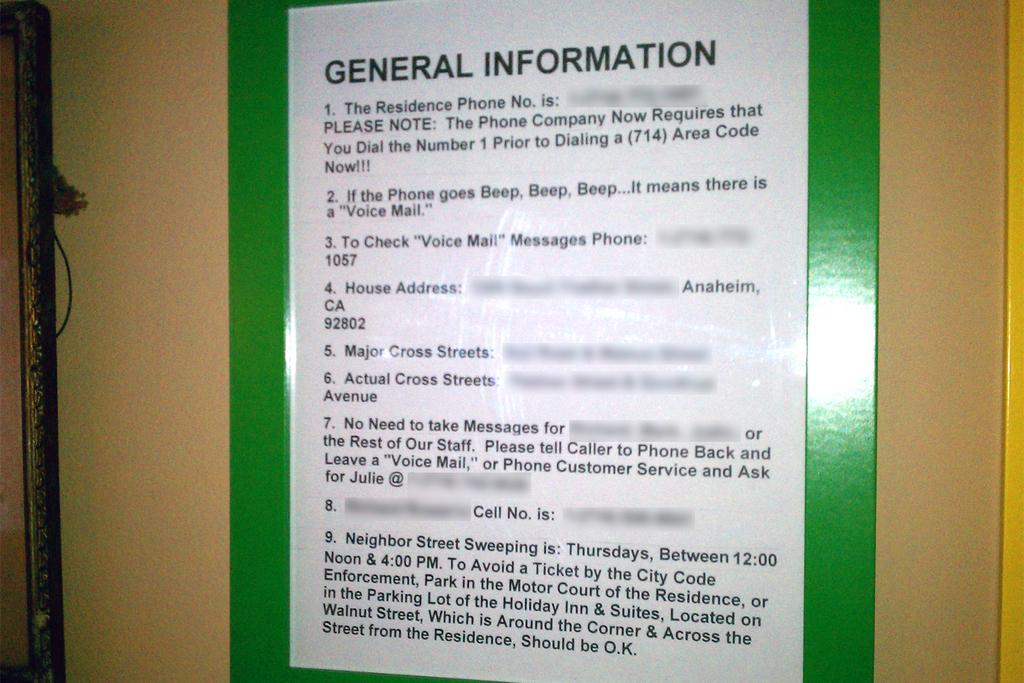<image>
Describe the image concisely. A written notice notes general information on a board. 